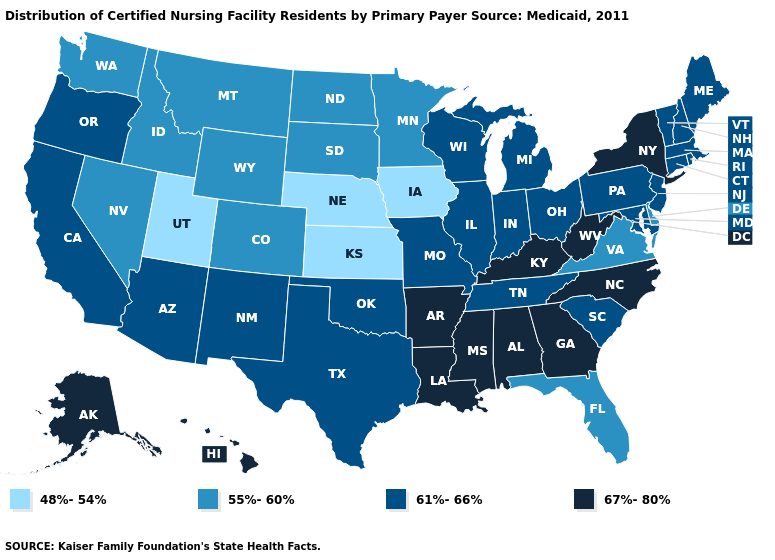What is the lowest value in states that border Texas?
Concise answer only. 61%-66%. Which states have the lowest value in the South?
Quick response, please. Delaware, Florida, Virginia. What is the value of Kansas?
Short answer required. 48%-54%. What is the value of Massachusetts?
Short answer required. 61%-66%. What is the value of Delaware?
Answer briefly. 55%-60%. Among the states that border Minnesota , which have the lowest value?
Write a very short answer. Iowa. Name the states that have a value in the range 67%-80%?
Keep it brief. Alabama, Alaska, Arkansas, Georgia, Hawaii, Kentucky, Louisiana, Mississippi, New York, North Carolina, West Virginia. Does Nebraska have the lowest value in the USA?
Short answer required. Yes. Does Ohio have a higher value than Kentucky?
Answer briefly. No. What is the highest value in states that border Maryland?
Give a very brief answer. 67%-80%. Does Wyoming have the highest value in the West?
Short answer required. No. Does the map have missing data?
Keep it brief. No. Which states have the highest value in the USA?
Give a very brief answer. Alabama, Alaska, Arkansas, Georgia, Hawaii, Kentucky, Louisiana, Mississippi, New York, North Carolina, West Virginia. Which states have the highest value in the USA?
Write a very short answer. Alabama, Alaska, Arkansas, Georgia, Hawaii, Kentucky, Louisiana, Mississippi, New York, North Carolina, West Virginia. What is the highest value in the USA?
Answer briefly. 67%-80%. 